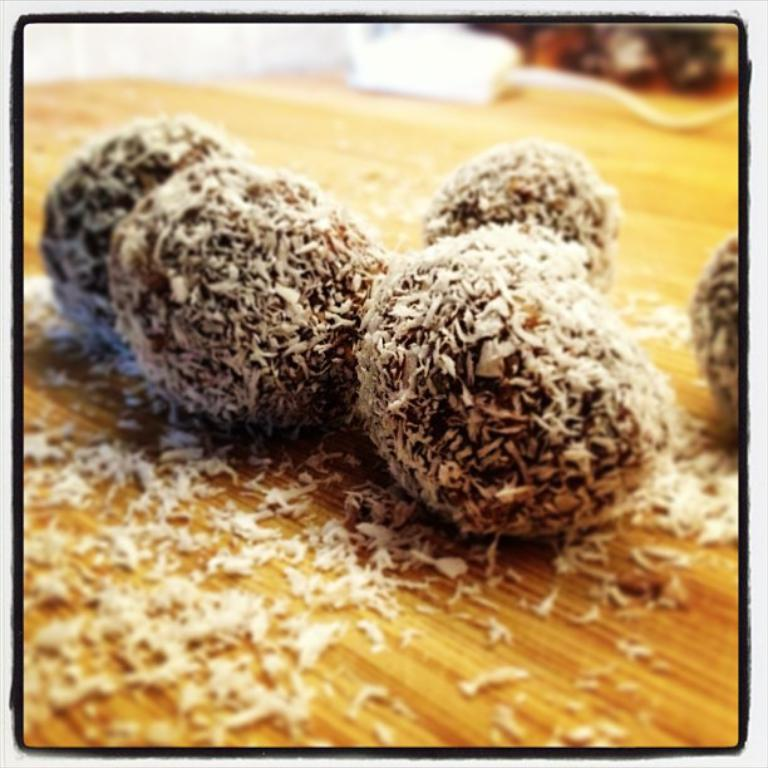What type of food can be seen in the image? There are sweets in the image. What is the texture of the sweets? The sweets have coconut powder on them. On what surface are the sweets placed? The sweets are on a wooden surface. What type of dinosaur can be seen in the image? There are no dinosaurs present in the image; it features sweets with coconut powder on a wooden surface. How many pins are visible in the image? There are no pins present in the image. 